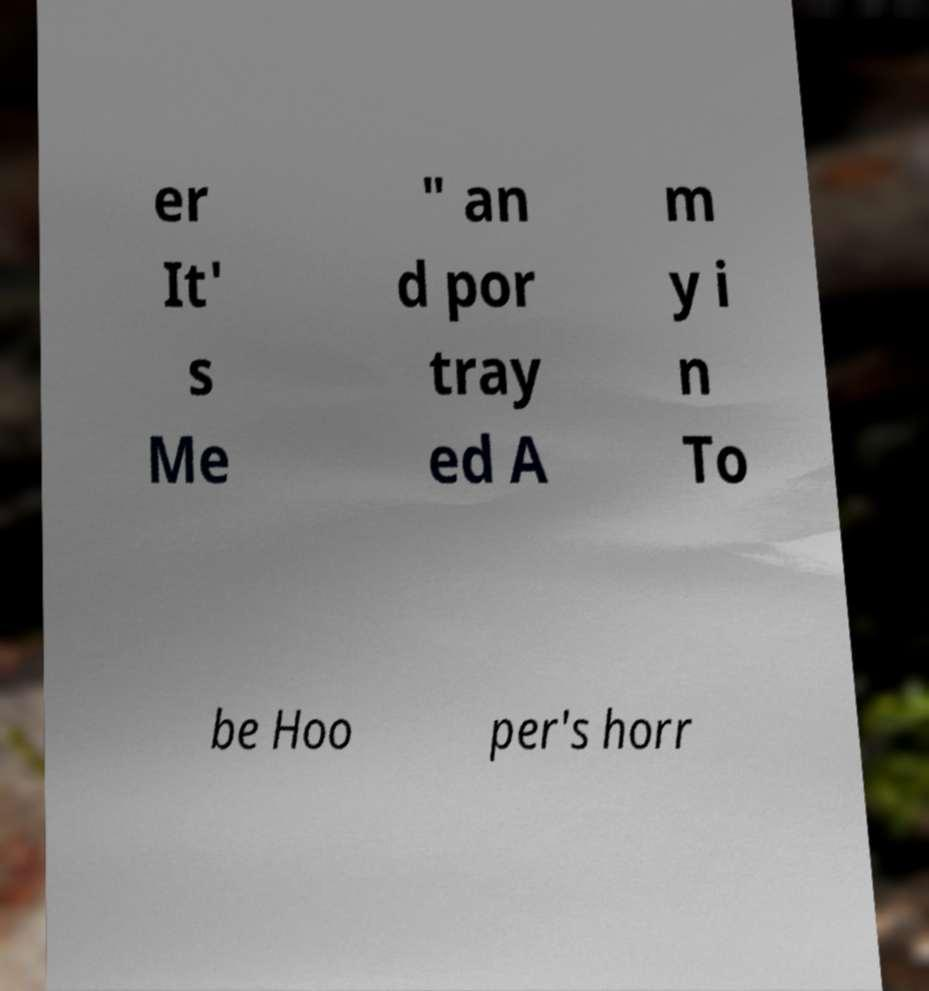What messages or text are displayed in this image? I need them in a readable, typed format. er It' s Me " an d por tray ed A m y i n To be Hoo per's horr 